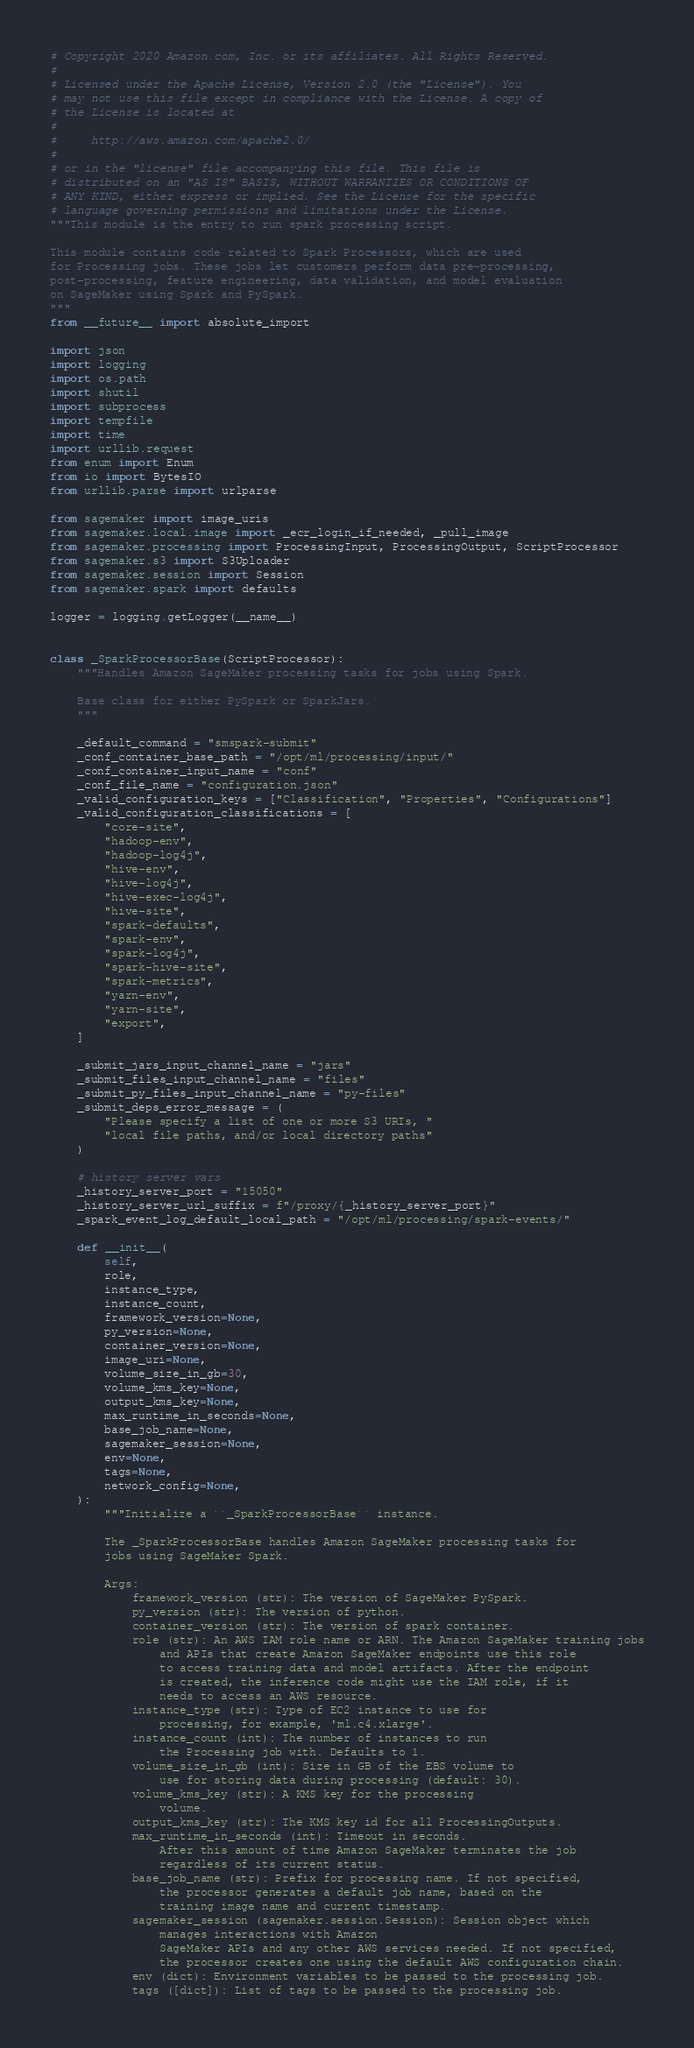Convert code to text. <code><loc_0><loc_0><loc_500><loc_500><_Python_># Copyright 2020 Amazon.com, Inc. or its affiliates. All Rights Reserved.
#
# Licensed under the Apache License, Version 2.0 (the "License"). You
# may not use this file except in compliance with the License. A copy of
# the License is located at
#
#     http://aws.amazon.com/apache2.0/
#
# or in the "license" file accompanying this file. This file is
# distributed on an "AS IS" BASIS, WITHOUT WARRANTIES OR CONDITIONS OF
# ANY KIND, either express or implied. See the License for the specific
# language governing permissions and limitations under the License.
"""This module is the entry to run spark processing script.

This module contains code related to Spark Processors, which are used
for Processing jobs. These jobs let customers perform data pre-processing,
post-processing, feature engineering, data validation, and model evaluation
on SageMaker using Spark and PySpark.
"""
from __future__ import absolute_import

import json
import logging
import os.path
import shutil
import subprocess
import tempfile
import time
import urllib.request
from enum import Enum
from io import BytesIO
from urllib.parse import urlparse

from sagemaker import image_uris
from sagemaker.local.image import _ecr_login_if_needed, _pull_image
from sagemaker.processing import ProcessingInput, ProcessingOutput, ScriptProcessor
from sagemaker.s3 import S3Uploader
from sagemaker.session import Session
from sagemaker.spark import defaults

logger = logging.getLogger(__name__)


class _SparkProcessorBase(ScriptProcessor):
    """Handles Amazon SageMaker processing tasks for jobs using Spark.

    Base class for either PySpark or SparkJars.
    """

    _default_command = "smspark-submit"
    _conf_container_base_path = "/opt/ml/processing/input/"
    _conf_container_input_name = "conf"
    _conf_file_name = "configuration.json"
    _valid_configuration_keys = ["Classification", "Properties", "Configurations"]
    _valid_configuration_classifications = [
        "core-site",
        "hadoop-env",
        "hadoop-log4j",
        "hive-env",
        "hive-log4j",
        "hive-exec-log4j",
        "hive-site",
        "spark-defaults",
        "spark-env",
        "spark-log4j",
        "spark-hive-site",
        "spark-metrics",
        "yarn-env",
        "yarn-site",
        "export",
    ]

    _submit_jars_input_channel_name = "jars"
    _submit_files_input_channel_name = "files"
    _submit_py_files_input_channel_name = "py-files"
    _submit_deps_error_message = (
        "Please specify a list of one or more S3 URIs, "
        "local file paths, and/or local directory paths"
    )

    # history server vars
    _history_server_port = "15050"
    _history_server_url_suffix = f"/proxy/{_history_server_port}"
    _spark_event_log_default_local_path = "/opt/ml/processing/spark-events/"

    def __init__(
        self,
        role,
        instance_type,
        instance_count,
        framework_version=None,
        py_version=None,
        container_version=None,
        image_uri=None,
        volume_size_in_gb=30,
        volume_kms_key=None,
        output_kms_key=None,
        max_runtime_in_seconds=None,
        base_job_name=None,
        sagemaker_session=None,
        env=None,
        tags=None,
        network_config=None,
    ):
        """Initialize a ``_SparkProcessorBase`` instance.

        The _SparkProcessorBase handles Amazon SageMaker processing tasks for
        jobs using SageMaker Spark.

        Args:
            framework_version (str): The version of SageMaker PySpark.
            py_version (str): The version of python.
            container_version (str): The version of spark container.
            role (str): An AWS IAM role name or ARN. The Amazon SageMaker training jobs
                and APIs that create Amazon SageMaker endpoints use this role
                to access training data and model artifacts. After the endpoint
                is created, the inference code might use the IAM role, if it
                needs to access an AWS resource.
            instance_type (str): Type of EC2 instance to use for
                processing, for example, 'ml.c4.xlarge'.
            instance_count (int): The number of instances to run
                the Processing job with. Defaults to 1.
            volume_size_in_gb (int): Size in GB of the EBS volume to
                use for storing data during processing (default: 30).
            volume_kms_key (str): A KMS key for the processing
                volume.
            output_kms_key (str): The KMS key id for all ProcessingOutputs.
            max_runtime_in_seconds (int): Timeout in seconds.
                After this amount of time Amazon SageMaker terminates the job
                regardless of its current status.
            base_job_name (str): Prefix for processing name. If not specified,
                the processor generates a default job name, based on the
                training image name and current timestamp.
            sagemaker_session (sagemaker.session.Session): Session object which
                manages interactions with Amazon
                SageMaker APIs and any other AWS services needed. If not specified,
                the processor creates one using the default AWS configuration chain.
            env (dict): Environment variables to be passed to the processing job.
            tags ([dict]): List of tags to be passed to the processing job.</code> 